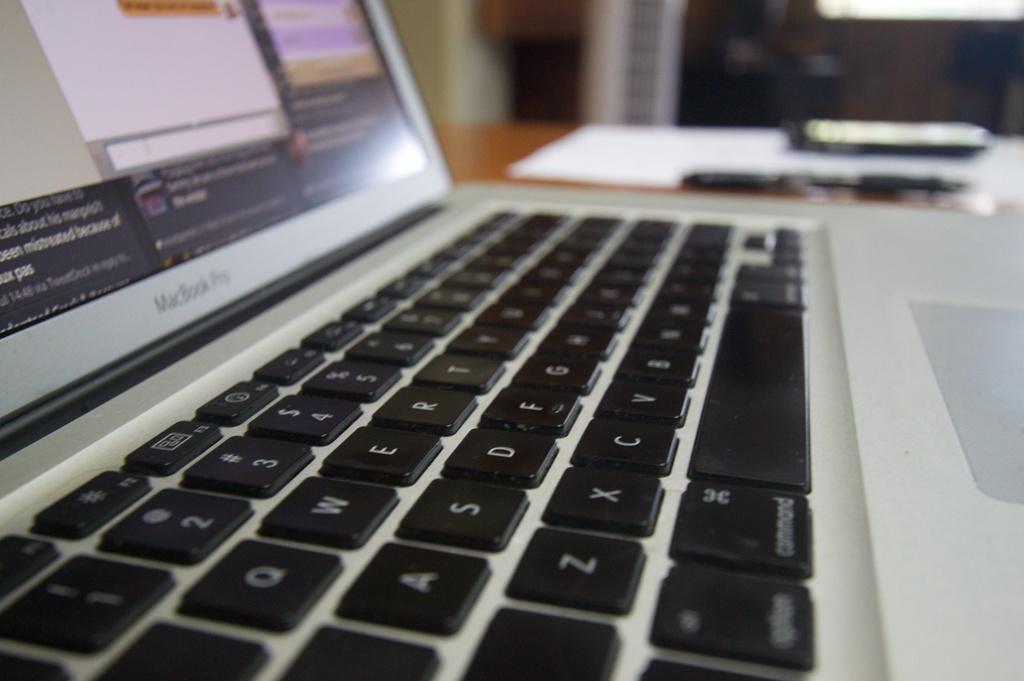How would you summarize this image in a sentence or two? There is a laptop, which is on the table, on which, there are other objects. In the background, there are other objects. 